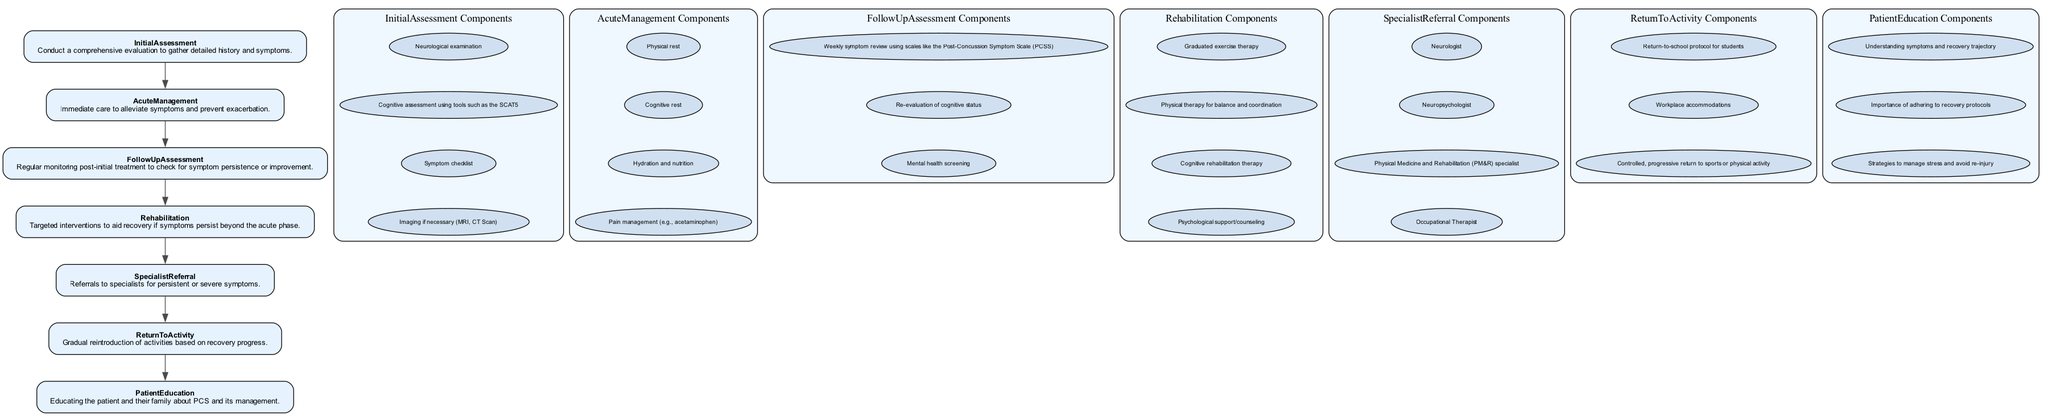What is the first stage in the clinical pathway? The diagram lists the stages in order from top to bottom, and the first stage mentioned is "Initial Assessment."
Answer: Initial Assessment How many components are listed under "Rehabilitation"? By examining the "Rehabilitation" stage in the diagram, it shows a total of four components outlined.
Answer: 4 Which stage immediately follows "Acute Management"? The stages are sequenced, and "Follow Up Assessment" is the next stage listed after "Acute Management."
Answer: Follow Up Assessment What type of assessment is repeated under "Follow Up Assessment"? The components under "Follow Up Assessment" include a weekly symptom review, which indicates that assessment occurs regularly.
Answer: Symptom review Is "Patient Education" a terminal stage in the pathway? Looking closely at the flow of the diagram, "Patient Education" is not followed by any other stages, making it a terminal stage.
Answer: Yes What is the primary purpose of "Acute Management"? The description provided for "Acute Management" emphasizes immediate care to alleviate symptoms, indicating its main purpose.
Answer: Alleviate symptoms Which specialists are referred to in the "Specialist Referral" stage? The components under "Specialist Referral" detail a list of specialists such as neurologist, neuropsychologist, and others, indicating their relevance to patient management.
Answer: Neurologist, Neuropsychologist, PM&R specialist, Occupational Therapist How does "Return to Activity" relate to recovery? The description for "Return to Activity" states it involves the gradual reintroduction of activities, reflecting the pathway's focus on a structured recovery approach.
Answer: Gradual reintroduction What component focuses on the mental health aspect during recovery? Among the components of "Follow Up Assessment," "Mental health screening" specifically addresses the mental health concerns of patients during recovery.
Answer: Mental health screening 